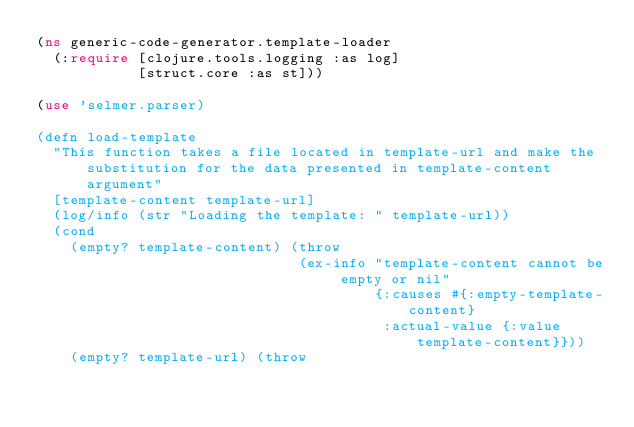<code> <loc_0><loc_0><loc_500><loc_500><_Clojure_>(ns generic-code-generator.template-loader
  (:require [clojure.tools.logging :as log]
            [struct.core :as st]))

(use 'selmer.parser)

(defn load-template
  "This function takes a file located in template-url and make the substitution for the data presented in template-content argument"
  [template-content template-url]
  (log/info (str "Loading the template: " template-url))
  (cond
    (empty? template-content) (throw
                               (ex-info "template-content cannot be empty or nil"
                                        {:causes #{:empty-template-content}
                                         :actual-value {:value template-content}}))
    (empty? template-url) (throw</code> 